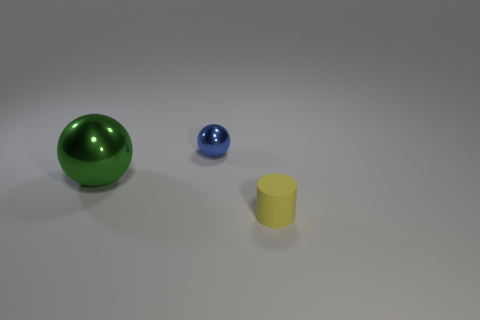There is a small object that is the same shape as the large thing; what color is it?
Offer a terse response. Blue. There is a object to the right of the tiny blue metallic sphere behind the metal thing on the left side of the blue thing; what is its shape?
Offer a very short reply. Cylinder. Do the rubber thing and the small metal object have the same shape?
Give a very brief answer. No. What shape is the tiny thing behind the tiny thing that is in front of the green ball?
Offer a very short reply. Sphere. Are there any tiny yellow cylinders?
Your response must be concise. Yes. There is a shiny sphere in front of the small thing that is left of the tiny cylinder; how many things are to the right of it?
Your response must be concise. 2. Is the shape of the big object the same as the thing that is right of the blue metal object?
Offer a very short reply. No. Are there more small objects than tiny metal things?
Keep it short and to the point. Yes. Is there any other thing that is the same size as the green object?
Your answer should be very brief. No. Does the tiny thing that is behind the tiny yellow thing have the same shape as the yellow rubber thing?
Your answer should be very brief. No. 